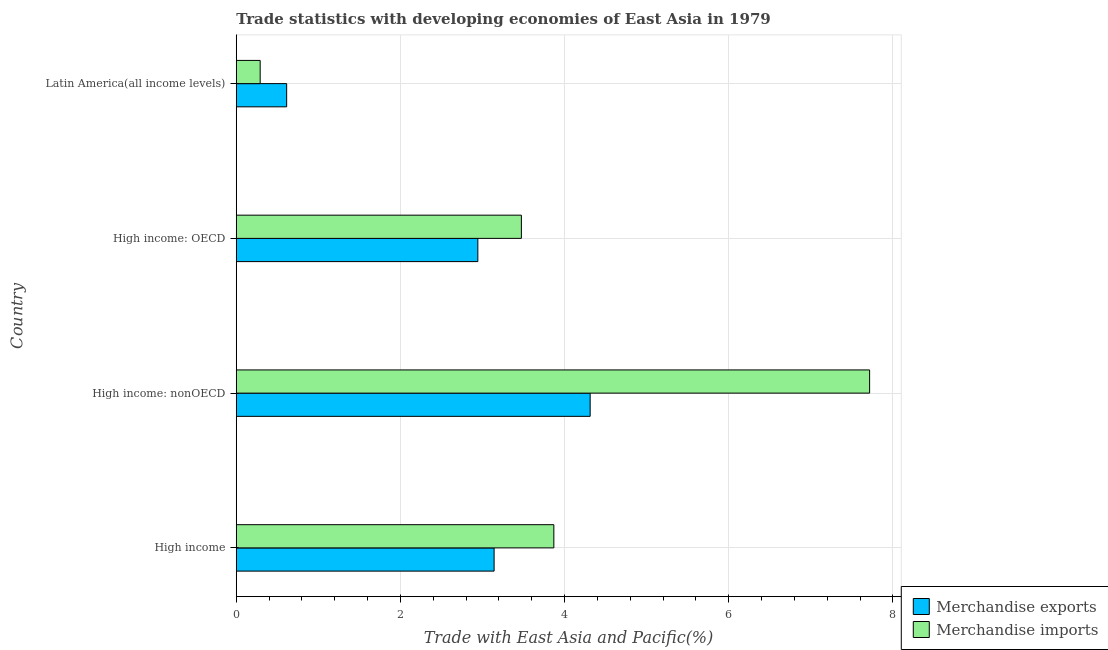How many groups of bars are there?
Make the answer very short. 4. How many bars are there on the 3rd tick from the bottom?
Keep it short and to the point. 2. What is the label of the 1st group of bars from the top?
Give a very brief answer. Latin America(all income levels). In how many cases, is the number of bars for a given country not equal to the number of legend labels?
Offer a terse response. 0. What is the merchandise exports in High income: OECD?
Make the answer very short. 2.94. Across all countries, what is the maximum merchandise imports?
Offer a terse response. 7.72. Across all countries, what is the minimum merchandise imports?
Give a very brief answer. 0.29. In which country was the merchandise exports maximum?
Make the answer very short. High income: nonOECD. In which country was the merchandise exports minimum?
Provide a succinct answer. Latin America(all income levels). What is the total merchandise exports in the graph?
Ensure brevity in your answer.  11.01. What is the difference between the merchandise exports in High income and that in High income: OECD?
Your answer should be compact. 0.2. What is the difference between the merchandise imports in High income and the merchandise exports in High income: nonOECD?
Offer a very short reply. -0.44. What is the average merchandise imports per country?
Your response must be concise. 3.84. What is the difference between the merchandise exports and merchandise imports in High income: nonOECD?
Keep it short and to the point. -3.4. What is the ratio of the merchandise exports in High income to that in High income: OECD?
Offer a very short reply. 1.07. Is the merchandise exports in High income less than that in High income: OECD?
Keep it short and to the point. No. Is the difference between the merchandise imports in High income: OECD and High income: nonOECD greater than the difference between the merchandise exports in High income: OECD and High income: nonOECD?
Provide a succinct answer. No. What is the difference between the highest and the second highest merchandise imports?
Your answer should be compact. 3.85. What is the difference between the highest and the lowest merchandise exports?
Ensure brevity in your answer.  3.7. In how many countries, is the merchandise imports greater than the average merchandise imports taken over all countries?
Your response must be concise. 2. What does the 2nd bar from the top in High income: nonOECD represents?
Offer a terse response. Merchandise exports. What does the 2nd bar from the bottom in High income represents?
Your response must be concise. Merchandise imports. How many bars are there?
Your answer should be very brief. 8. Are all the bars in the graph horizontal?
Your answer should be compact. Yes. How many countries are there in the graph?
Provide a succinct answer. 4. What is the difference between two consecutive major ticks on the X-axis?
Your answer should be very brief. 2. Are the values on the major ticks of X-axis written in scientific E-notation?
Offer a terse response. No. Does the graph contain any zero values?
Make the answer very short. No. Does the graph contain grids?
Your response must be concise. Yes. Where does the legend appear in the graph?
Make the answer very short. Bottom right. How many legend labels are there?
Offer a very short reply. 2. How are the legend labels stacked?
Your response must be concise. Vertical. What is the title of the graph?
Give a very brief answer. Trade statistics with developing economies of East Asia in 1979. Does "Female entrants" appear as one of the legend labels in the graph?
Keep it short and to the point. No. What is the label or title of the X-axis?
Ensure brevity in your answer.  Trade with East Asia and Pacific(%). What is the label or title of the Y-axis?
Give a very brief answer. Country. What is the Trade with East Asia and Pacific(%) of Merchandise exports in High income?
Offer a very short reply. 3.14. What is the Trade with East Asia and Pacific(%) in Merchandise imports in High income?
Provide a succinct answer. 3.87. What is the Trade with East Asia and Pacific(%) in Merchandise exports in High income: nonOECD?
Your response must be concise. 4.31. What is the Trade with East Asia and Pacific(%) in Merchandise imports in High income: nonOECD?
Ensure brevity in your answer.  7.72. What is the Trade with East Asia and Pacific(%) of Merchandise exports in High income: OECD?
Provide a short and direct response. 2.94. What is the Trade with East Asia and Pacific(%) in Merchandise imports in High income: OECD?
Provide a short and direct response. 3.47. What is the Trade with East Asia and Pacific(%) in Merchandise exports in Latin America(all income levels)?
Offer a very short reply. 0.61. What is the Trade with East Asia and Pacific(%) of Merchandise imports in Latin America(all income levels)?
Give a very brief answer. 0.29. Across all countries, what is the maximum Trade with East Asia and Pacific(%) in Merchandise exports?
Give a very brief answer. 4.31. Across all countries, what is the maximum Trade with East Asia and Pacific(%) in Merchandise imports?
Your answer should be compact. 7.72. Across all countries, what is the minimum Trade with East Asia and Pacific(%) of Merchandise exports?
Keep it short and to the point. 0.61. Across all countries, what is the minimum Trade with East Asia and Pacific(%) of Merchandise imports?
Your response must be concise. 0.29. What is the total Trade with East Asia and Pacific(%) of Merchandise exports in the graph?
Offer a terse response. 11.01. What is the total Trade with East Asia and Pacific(%) of Merchandise imports in the graph?
Make the answer very short. 15.35. What is the difference between the Trade with East Asia and Pacific(%) of Merchandise exports in High income and that in High income: nonOECD?
Your response must be concise. -1.17. What is the difference between the Trade with East Asia and Pacific(%) of Merchandise imports in High income and that in High income: nonOECD?
Your answer should be compact. -3.85. What is the difference between the Trade with East Asia and Pacific(%) of Merchandise exports in High income and that in High income: OECD?
Ensure brevity in your answer.  0.2. What is the difference between the Trade with East Asia and Pacific(%) of Merchandise imports in High income and that in High income: OECD?
Provide a succinct answer. 0.4. What is the difference between the Trade with East Asia and Pacific(%) in Merchandise exports in High income and that in Latin America(all income levels)?
Your answer should be very brief. 2.53. What is the difference between the Trade with East Asia and Pacific(%) of Merchandise imports in High income and that in Latin America(all income levels)?
Your answer should be compact. 3.58. What is the difference between the Trade with East Asia and Pacific(%) in Merchandise exports in High income: nonOECD and that in High income: OECD?
Ensure brevity in your answer.  1.37. What is the difference between the Trade with East Asia and Pacific(%) in Merchandise imports in High income: nonOECD and that in High income: OECD?
Offer a very short reply. 4.24. What is the difference between the Trade with East Asia and Pacific(%) in Merchandise exports in High income: nonOECD and that in Latin America(all income levels)?
Your response must be concise. 3.7. What is the difference between the Trade with East Asia and Pacific(%) of Merchandise imports in High income: nonOECD and that in Latin America(all income levels)?
Keep it short and to the point. 7.42. What is the difference between the Trade with East Asia and Pacific(%) of Merchandise exports in High income: OECD and that in Latin America(all income levels)?
Make the answer very short. 2.33. What is the difference between the Trade with East Asia and Pacific(%) of Merchandise imports in High income: OECD and that in Latin America(all income levels)?
Your response must be concise. 3.18. What is the difference between the Trade with East Asia and Pacific(%) of Merchandise exports in High income and the Trade with East Asia and Pacific(%) of Merchandise imports in High income: nonOECD?
Your answer should be very brief. -4.57. What is the difference between the Trade with East Asia and Pacific(%) in Merchandise exports in High income and the Trade with East Asia and Pacific(%) in Merchandise imports in High income: OECD?
Your answer should be very brief. -0.33. What is the difference between the Trade with East Asia and Pacific(%) in Merchandise exports in High income and the Trade with East Asia and Pacific(%) in Merchandise imports in Latin America(all income levels)?
Make the answer very short. 2.85. What is the difference between the Trade with East Asia and Pacific(%) of Merchandise exports in High income: nonOECD and the Trade with East Asia and Pacific(%) of Merchandise imports in High income: OECD?
Give a very brief answer. 0.84. What is the difference between the Trade with East Asia and Pacific(%) in Merchandise exports in High income: nonOECD and the Trade with East Asia and Pacific(%) in Merchandise imports in Latin America(all income levels)?
Provide a short and direct response. 4.02. What is the difference between the Trade with East Asia and Pacific(%) of Merchandise exports in High income: OECD and the Trade with East Asia and Pacific(%) of Merchandise imports in Latin America(all income levels)?
Provide a short and direct response. 2.65. What is the average Trade with East Asia and Pacific(%) of Merchandise exports per country?
Make the answer very short. 2.75. What is the average Trade with East Asia and Pacific(%) of Merchandise imports per country?
Offer a very short reply. 3.84. What is the difference between the Trade with East Asia and Pacific(%) of Merchandise exports and Trade with East Asia and Pacific(%) of Merchandise imports in High income?
Your response must be concise. -0.73. What is the difference between the Trade with East Asia and Pacific(%) of Merchandise exports and Trade with East Asia and Pacific(%) of Merchandise imports in High income: nonOECD?
Offer a terse response. -3.4. What is the difference between the Trade with East Asia and Pacific(%) in Merchandise exports and Trade with East Asia and Pacific(%) in Merchandise imports in High income: OECD?
Your answer should be very brief. -0.53. What is the difference between the Trade with East Asia and Pacific(%) of Merchandise exports and Trade with East Asia and Pacific(%) of Merchandise imports in Latin America(all income levels)?
Your answer should be compact. 0.32. What is the ratio of the Trade with East Asia and Pacific(%) of Merchandise exports in High income to that in High income: nonOECD?
Offer a very short reply. 0.73. What is the ratio of the Trade with East Asia and Pacific(%) of Merchandise imports in High income to that in High income: nonOECD?
Give a very brief answer. 0.5. What is the ratio of the Trade with East Asia and Pacific(%) in Merchandise exports in High income to that in High income: OECD?
Your response must be concise. 1.07. What is the ratio of the Trade with East Asia and Pacific(%) of Merchandise imports in High income to that in High income: OECD?
Offer a very short reply. 1.11. What is the ratio of the Trade with East Asia and Pacific(%) of Merchandise exports in High income to that in Latin America(all income levels)?
Keep it short and to the point. 5.12. What is the ratio of the Trade with East Asia and Pacific(%) in Merchandise imports in High income to that in Latin America(all income levels)?
Your response must be concise. 13.28. What is the ratio of the Trade with East Asia and Pacific(%) of Merchandise exports in High income: nonOECD to that in High income: OECD?
Make the answer very short. 1.47. What is the ratio of the Trade with East Asia and Pacific(%) of Merchandise imports in High income: nonOECD to that in High income: OECD?
Provide a succinct answer. 2.22. What is the ratio of the Trade with East Asia and Pacific(%) of Merchandise exports in High income: nonOECD to that in Latin America(all income levels)?
Make the answer very short. 7.02. What is the ratio of the Trade with East Asia and Pacific(%) in Merchandise imports in High income: nonOECD to that in Latin America(all income levels)?
Your answer should be very brief. 26.48. What is the ratio of the Trade with East Asia and Pacific(%) in Merchandise exports in High income: OECD to that in Latin America(all income levels)?
Give a very brief answer. 4.79. What is the ratio of the Trade with East Asia and Pacific(%) of Merchandise imports in High income: OECD to that in Latin America(all income levels)?
Provide a succinct answer. 11.92. What is the difference between the highest and the second highest Trade with East Asia and Pacific(%) of Merchandise exports?
Your answer should be compact. 1.17. What is the difference between the highest and the second highest Trade with East Asia and Pacific(%) of Merchandise imports?
Ensure brevity in your answer.  3.85. What is the difference between the highest and the lowest Trade with East Asia and Pacific(%) of Merchandise exports?
Offer a very short reply. 3.7. What is the difference between the highest and the lowest Trade with East Asia and Pacific(%) of Merchandise imports?
Your answer should be very brief. 7.42. 